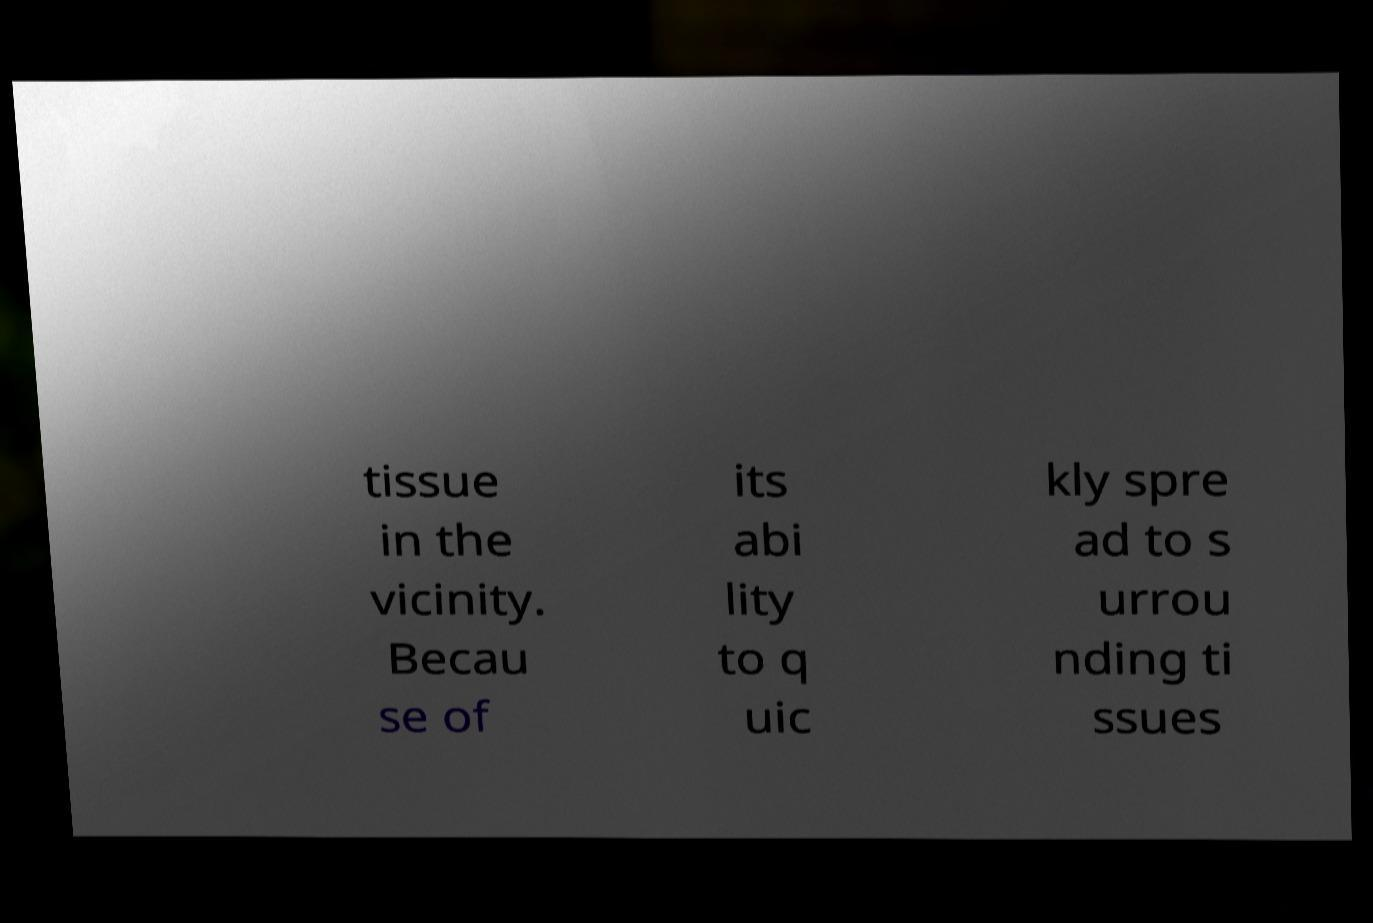There's text embedded in this image that I need extracted. Can you transcribe it verbatim? tissue in the vicinity. Becau se of its abi lity to q uic kly spre ad to s urrou nding ti ssues 